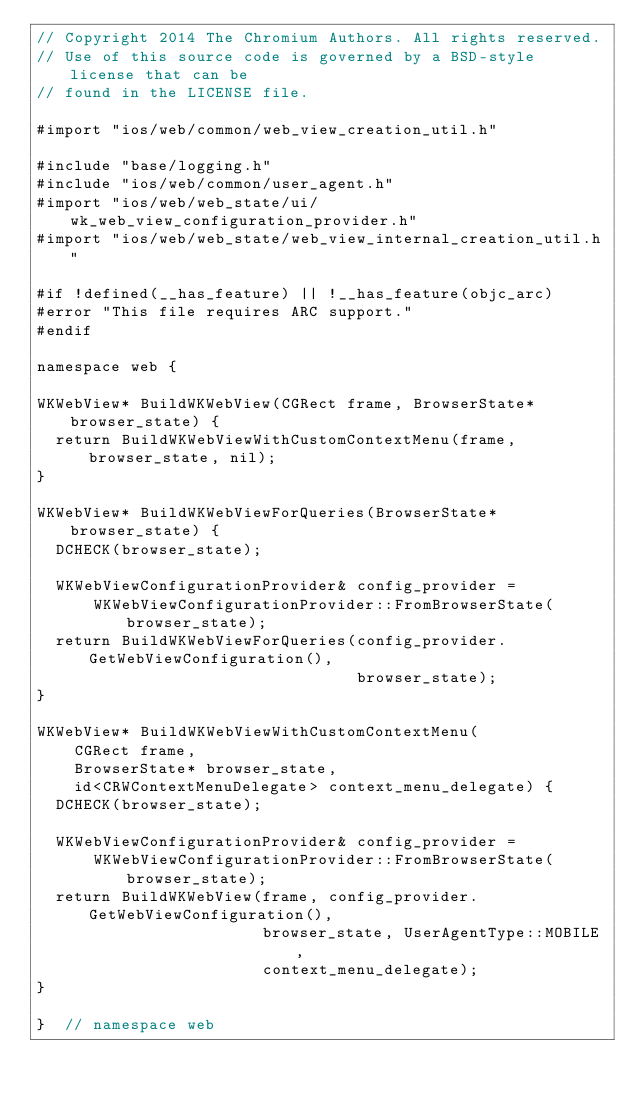Convert code to text. <code><loc_0><loc_0><loc_500><loc_500><_ObjectiveC_>// Copyright 2014 The Chromium Authors. All rights reserved.
// Use of this source code is governed by a BSD-style license that can be
// found in the LICENSE file.

#import "ios/web/common/web_view_creation_util.h"

#include "base/logging.h"
#include "ios/web/common/user_agent.h"
#import "ios/web/web_state/ui/wk_web_view_configuration_provider.h"
#import "ios/web/web_state/web_view_internal_creation_util.h"

#if !defined(__has_feature) || !__has_feature(objc_arc)
#error "This file requires ARC support."
#endif

namespace web {

WKWebView* BuildWKWebView(CGRect frame, BrowserState* browser_state) {
  return BuildWKWebViewWithCustomContextMenu(frame, browser_state, nil);
}

WKWebView* BuildWKWebViewForQueries(BrowserState* browser_state) {
  DCHECK(browser_state);

  WKWebViewConfigurationProvider& config_provider =
      WKWebViewConfigurationProvider::FromBrowserState(browser_state);
  return BuildWKWebViewForQueries(config_provider.GetWebViewConfiguration(),
                                  browser_state);
}

WKWebView* BuildWKWebViewWithCustomContextMenu(
    CGRect frame,
    BrowserState* browser_state,
    id<CRWContextMenuDelegate> context_menu_delegate) {
  DCHECK(browser_state);

  WKWebViewConfigurationProvider& config_provider =
      WKWebViewConfigurationProvider::FromBrowserState(browser_state);
  return BuildWKWebView(frame, config_provider.GetWebViewConfiguration(),
                        browser_state, UserAgentType::MOBILE,
                        context_menu_delegate);
}

}  // namespace web
</code> 